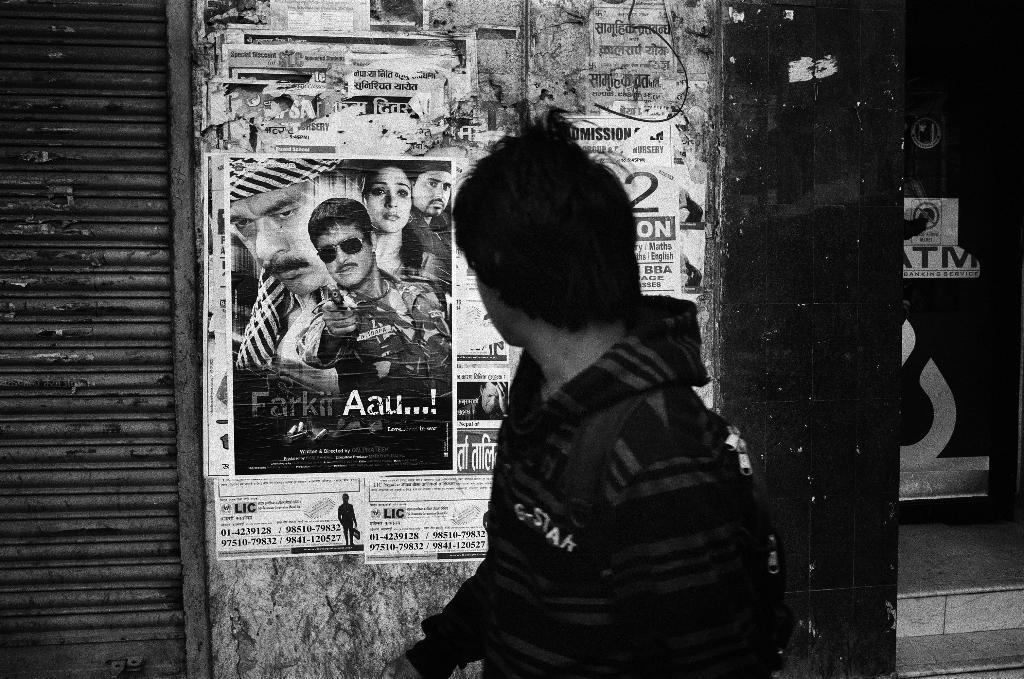Could you give a brief overview of what you see in this image? In this image I see this is a black and white picture and I see a man over here who is wearing a hoodie and I see something is written over here. In the background I see the wall on which there are many papers and on this paper I see pictures of few persons and I see something is written on these papers. 